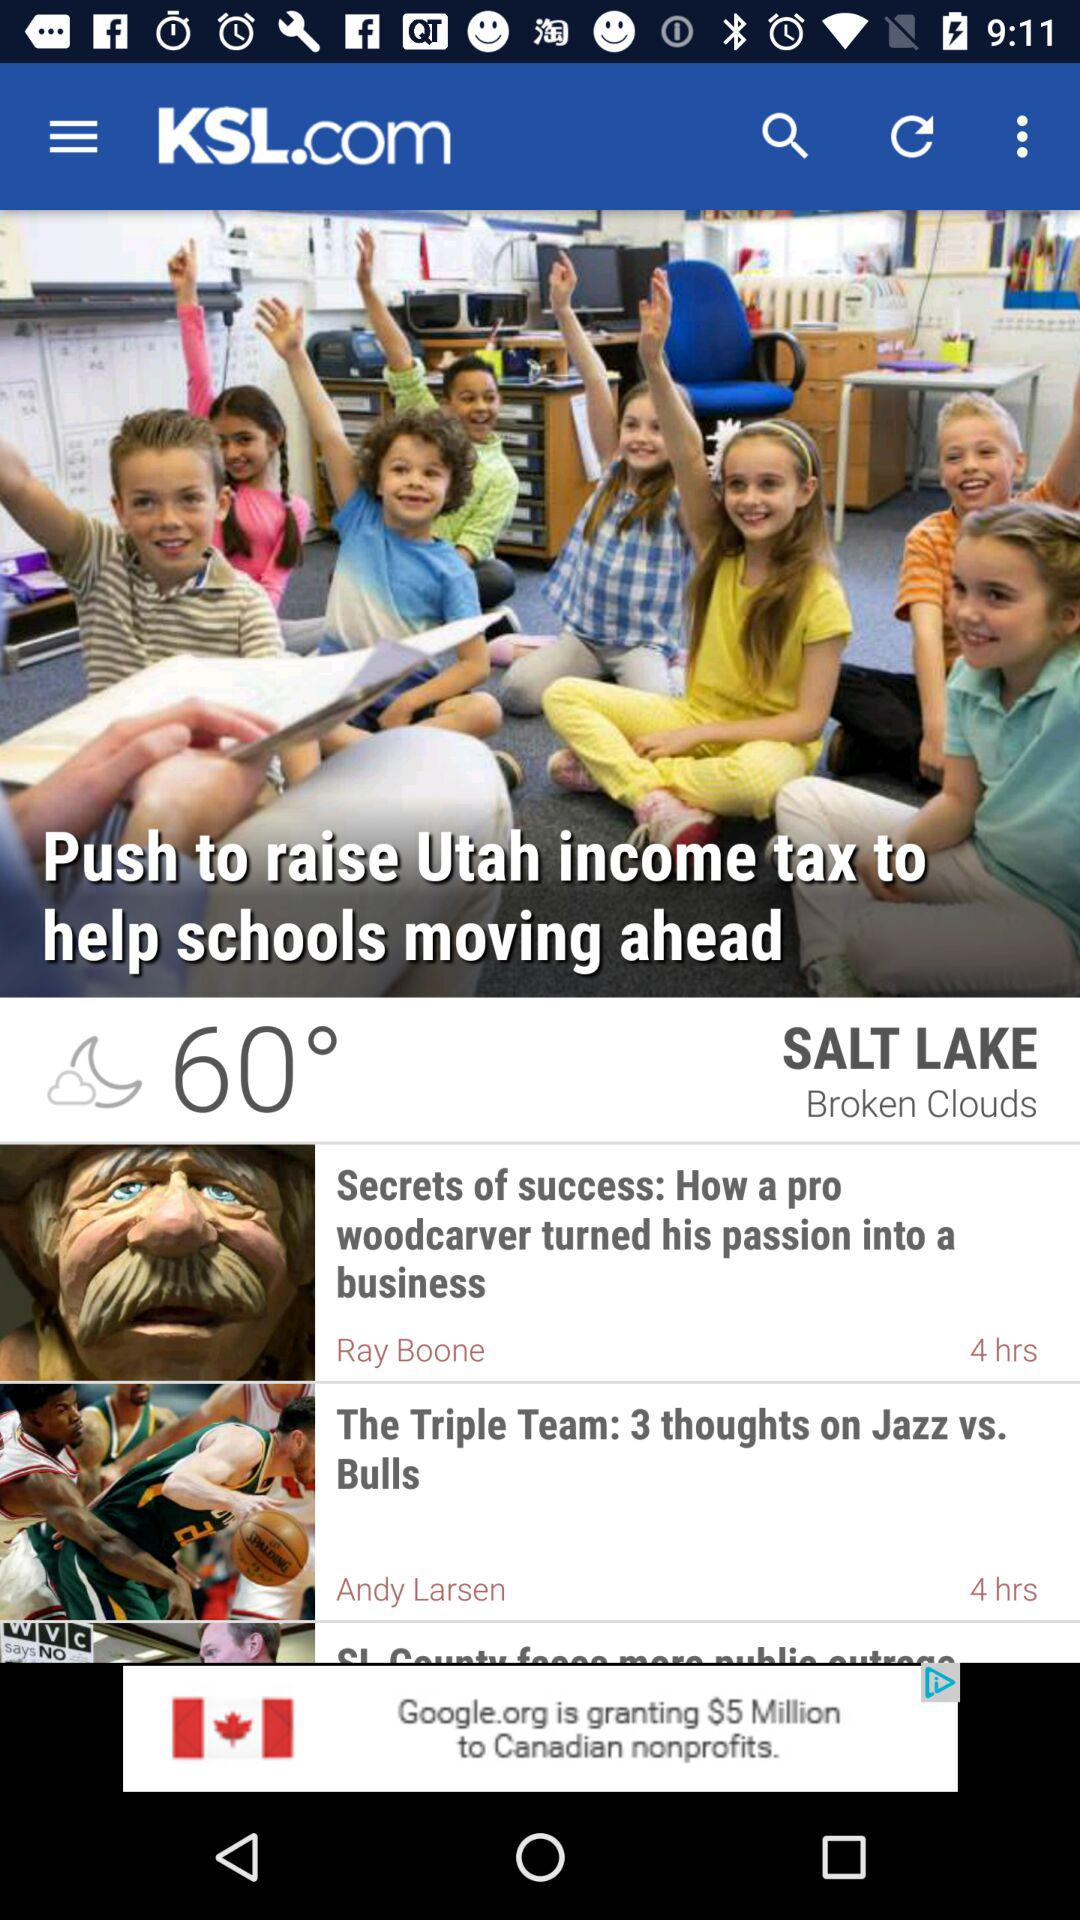What is the temperature shown on the screen? The shown temperature is 60°. 